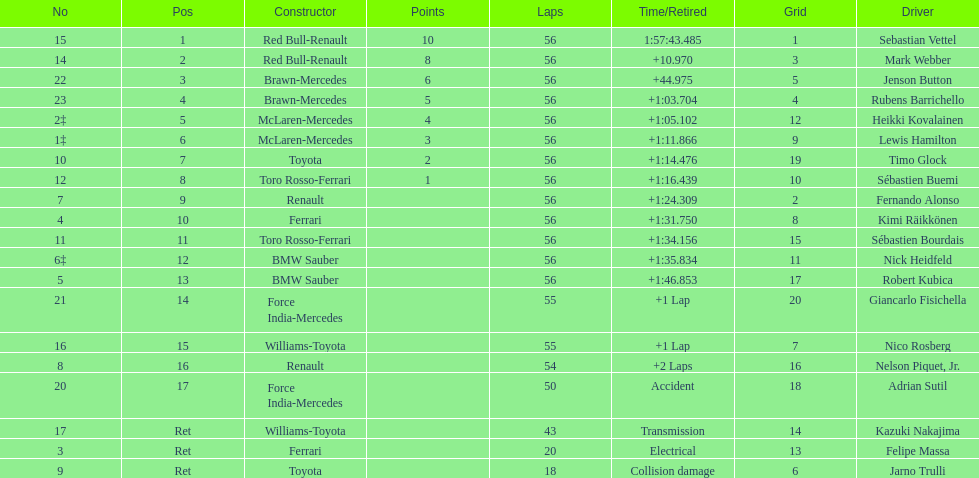Who are all of the drivers? Sebastian Vettel, Mark Webber, Jenson Button, Rubens Barrichello, Heikki Kovalainen, Lewis Hamilton, Timo Glock, Sébastien Buemi, Fernando Alonso, Kimi Räikkönen, Sébastien Bourdais, Nick Heidfeld, Robert Kubica, Giancarlo Fisichella, Nico Rosberg, Nelson Piquet, Jr., Adrian Sutil, Kazuki Nakajima, Felipe Massa, Jarno Trulli. Who were their constructors? Red Bull-Renault, Red Bull-Renault, Brawn-Mercedes, Brawn-Mercedes, McLaren-Mercedes, McLaren-Mercedes, Toyota, Toro Rosso-Ferrari, Renault, Ferrari, Toro Rosso-Ferrari, BMW Sauber, BMW Sauber, Force India-Mercedes, Williams-Toyota, Renault, Force India-Mercedes, Williams-Toyota, Ferrari, Toyota. Who was the first listed driver to not drive a ferrari?? Sebastian Vettel. 